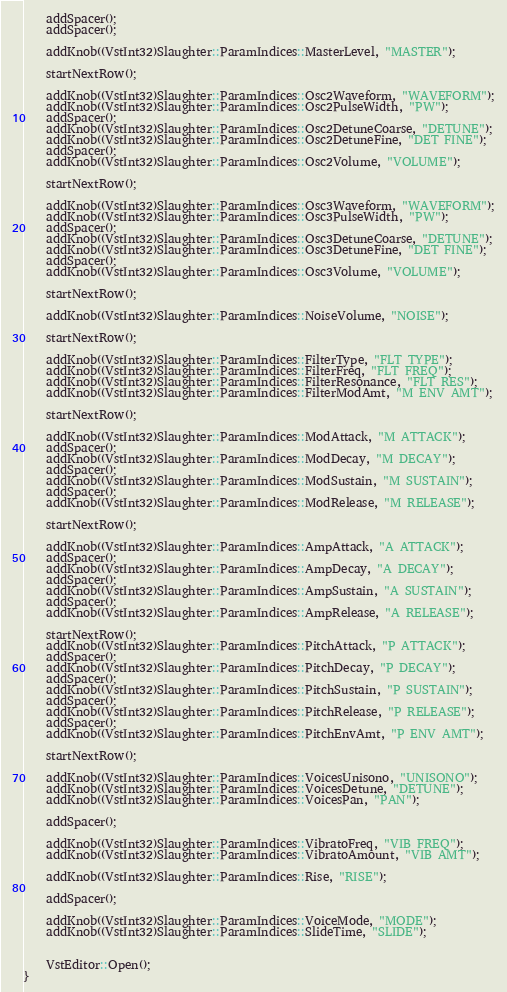<code> <loc_0><loc_0><loc_500><loc_500><_C++_>	addSpacer();
	addSpacer();

	addKnob((VstInt32)Slaughter::ParamIndices::MasterLevel, "MASTER");
	
	startNextRow();

	addKnob((VstInt32)Slaughter::ParamIndices::Osc2Waveform, "WAVEFORM");
	addKnob((VstInt32)Slaughter::ParamIndices::Osc2PulseWidth, "PW");
	addSpacer();
	addKnob((VstInt32)Slaughter::ParamIndices::Osc2DetuneCoarse, "DETUNE");
	addKnob((VstInt32)Slaughter::ParamIndices::Osc2DetuneFine, "DET FINE");
	addSpacer();
	addKnob((VstInt32)Slaughter::ParamIndices::Osc2Volume, "VOLUME");

	startNextRow();

	addKnob((VstInt32)Slaughter::ParamIndices::Osc3Waveform, "WAVEFORM");
	addKnob((VstInt32)Slaughter::ParamIndices::Osc3PulseWidth, "PW");
	addSpacer();
	addKnob((VstInt32)Slaughter::ParamIndices::Osc3DetuneCoarse, "DETUNE");
	addKnob((VstInt32)Slaughter::ParamIndices::Osc3DetuneFine, "DET FINE");
	addSpacer();
	addKnob((VstInt32)Slaughter::ParamIndices::Osc3Volume, "VOLUME");

	startNextRow();

	addKnob((VstInt32)Slaughter::ParamIndices::NoiseVolume, "NOISE");

	startNextRow();

	addKnob((VstInt32)Slaughter::ParamIndices::FilterType, "FLT TYPE");
	addKnob((VstInt32)Slaughter::ParamIndices::FilterFreq, "FLT FREQ");
	addKnob((VstInt32)Slaughter::ParamIndices::FilterResonance, "FLT RES");
	addKnob((VstInt32)Slaughter::ParamIndices::FilterModAmt, "M ENV AMT");

	startNextRow();

	addKnob((VstInt32)Slaughter::ParamIndices::ModAttack, "M ATTACK");
	addSpacer();
	addKnob((VstInt32)Slaughter::ParamIndices::ModDecay, "M DECAY");
	addSpacer();
	addKnob((VstInt32)Slaughter::ParamIndices::ModSustain, "M SUSTAIN");
	addSpacer();
	addKnob((VstInt32)Slaughter::ParamIndices::ModRelease, "M RELEASE");

	startNextRow();

	addKnob((VstInt32)Slaughter::ParamIndices::AmpAttack, "A ATTACK");
	addSpacer();
	addKnob((VstInt32)Slaughter::ParamIndices::AmpDecay, "A DECAY");
	addSpacer();
	addKnob((VstInt32)Slaughter::ParamIndices::AmpSustain, "A SUSTAIN");
	addSpacer();
	addKnob((VstInt32)Slaughter::ParamIndices::AmpRelease, "A RELEASE");

	startNextRow();
	addKnob((VstInt32)Slaughter::ParamIndices::PitchAttack, "P ATTACK");
	addSpacer();
	addKnob((VstInt32)Slaughter::ParamIndices::PitchDecay, "P DECAY");
	addSpacer();
	addKnob((VstInt32)Slaughter::ParamIndices::PitchSustain, "P SUSTAIN");
	addSpacer();
	addKnob((VstInt32)Slaughter::ParamIndices::PitchRelease, "P RELEASE");
	addSpacer();
	addKnob((VstInt32)Slaughter::ParamIndices::PitchEnvAmt, "P ENV AMT");

	startNextRow();

	addKnob((VstInt32)Slaughter::ParamIndices::VoicesUnisono, "UNISONO");
	addKnob((VstInt32)Slaughter::ParamIndices::VoicesDetune, "DETUNE");
	addKnob((VstInt32)Slaughter::ParamIndices::VoicesPan, "PAN");

	addSpacer();

	addKnob((VstInt32)Slaughter::ParamIndices::VibratoFreq, "VIB FREQ");
	addKnob((VstInt32)Slaughter::ParamIndices::VibratoAmount, "VIB AMT");

	addKnob((VstInt32)Slaughter::ParamIndices::Rise, "RISE");

	addSpacer();

	addKnob((VstInt32)Slaughter::ParamIndices::VoiceMode, "MODE");
	addKnob((VstInt32)Slaughter::ParamIndices::SlideTime, "SLIDE");


	VstEditor::Open();
}
</code> 